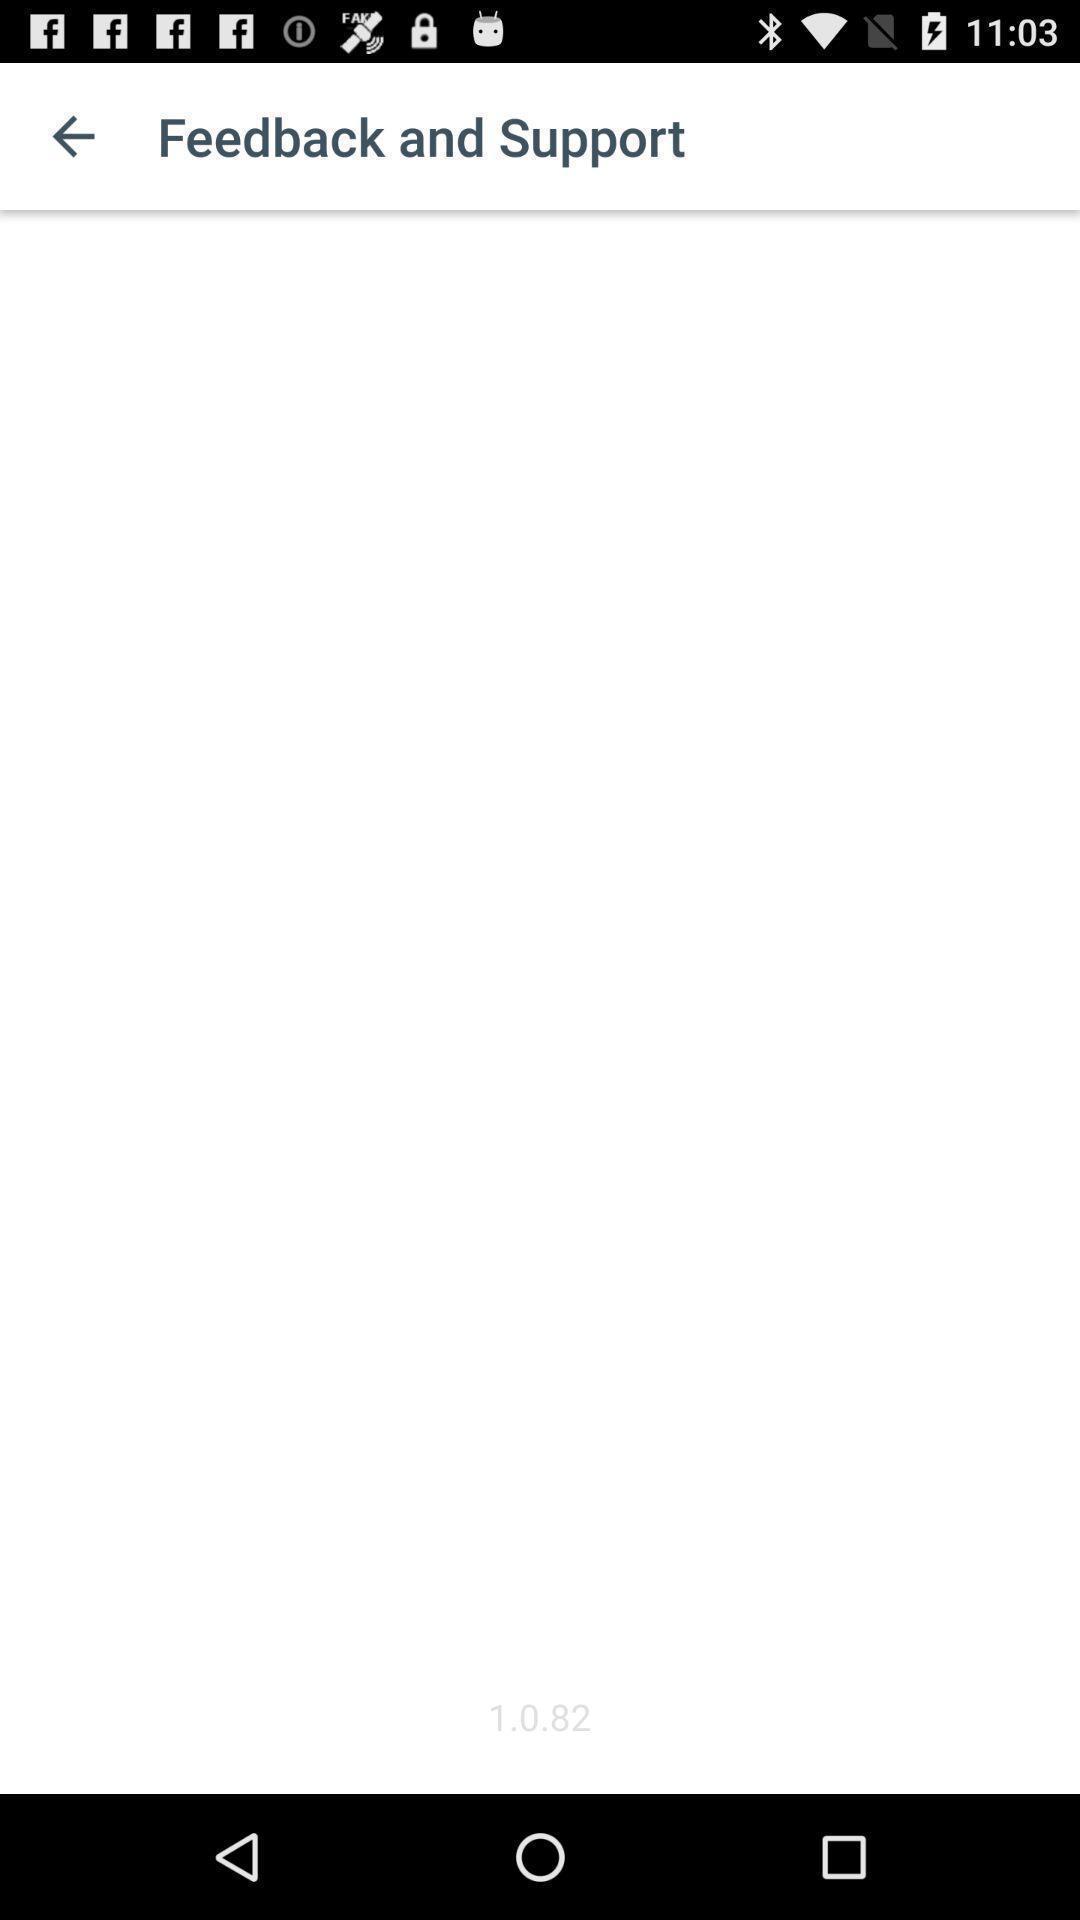Please provide a description for this image. Screen showing feedback page. 